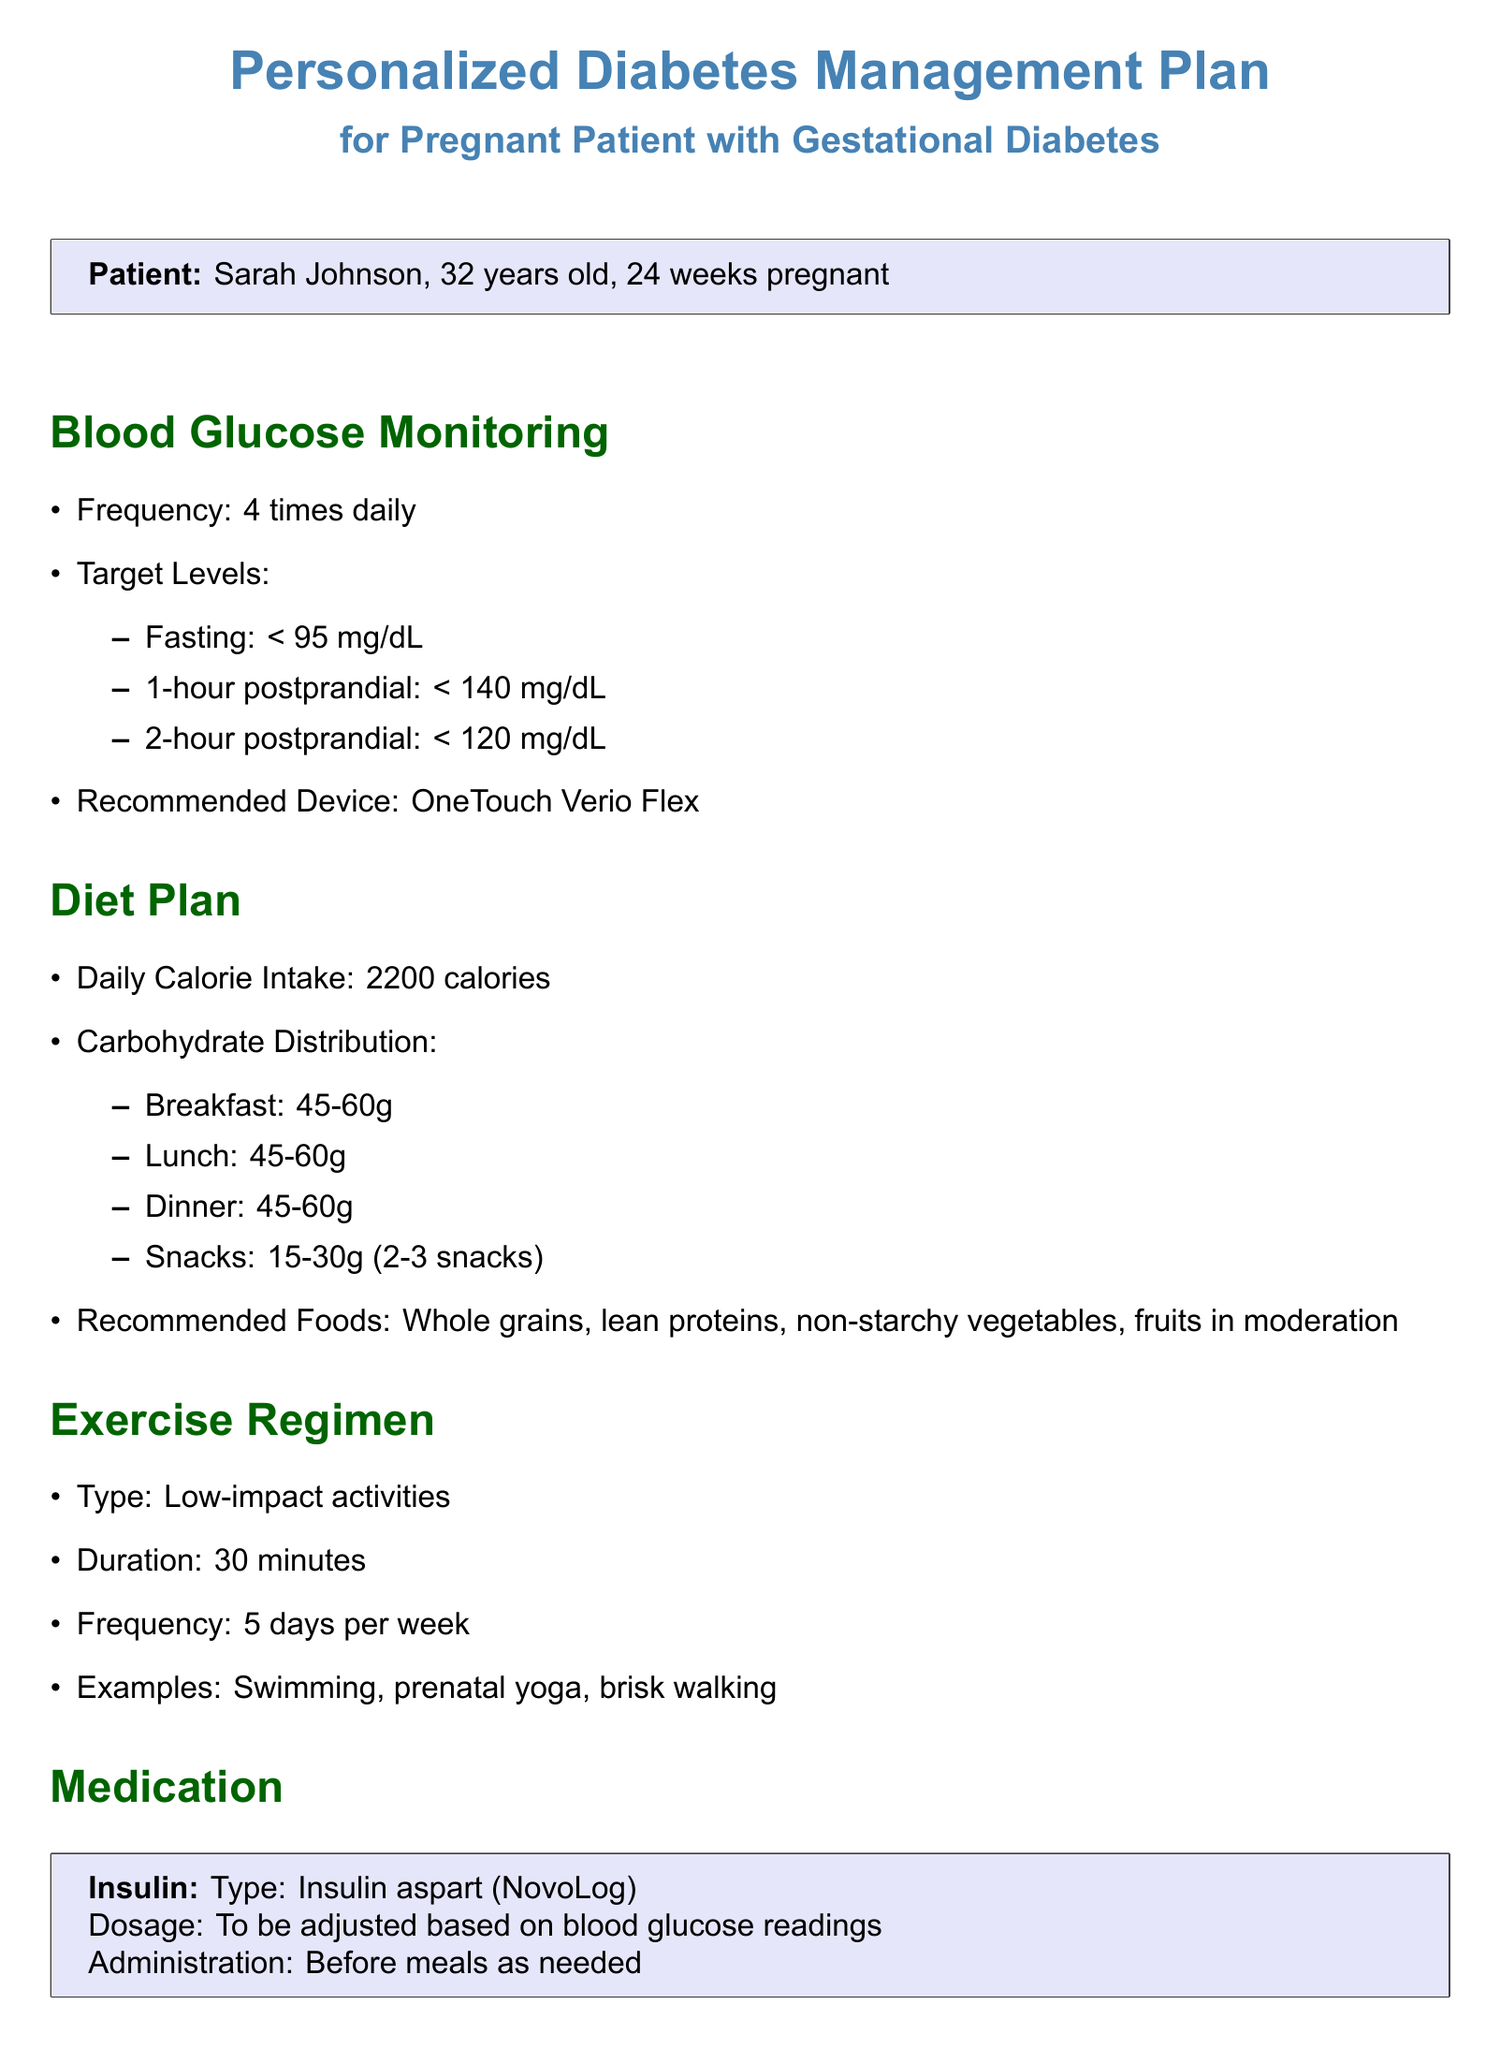What is the patient's name? The patient's name is listed in the patient information section of the document.
Answer: Sarah Johnson How many weeks pregnant is Sarah? The document specifies the patient's week of pregnancy.
Answer: 24 What is the target fasting blood glucose level? The document provides specific target levels for blood glucose monitoring.
Answer: < 95 mg/dL What is the recommended daily calorie intake? The document outlines the dietary plan for the patient, including calorie intake.
Answer: 2200 How often should blood glucose be monitored? The frequency of blood glucose monitoring is explicitly stated in the document.
Answer: 4 times daily What type of insulin is prescribed? The document specifies the type of medication prescribed for insulin management.
Answer: Insulin aspart (NovoLog) List one example of exercise recommended in the regimen. The exercise regimen section includes examples of activities.
Answer: Swimming When is the next follow-up appointment scheduled? The document specifies the date of the next appointment in the follow-up section.
Answer: May 15, 2023 Who are the members of the healthcare team? The document lists the healthcare providers involved in the patient's care.
Answer: Dr. Emily Chen, Nurse Sarah Thompson, Lisa Brown 